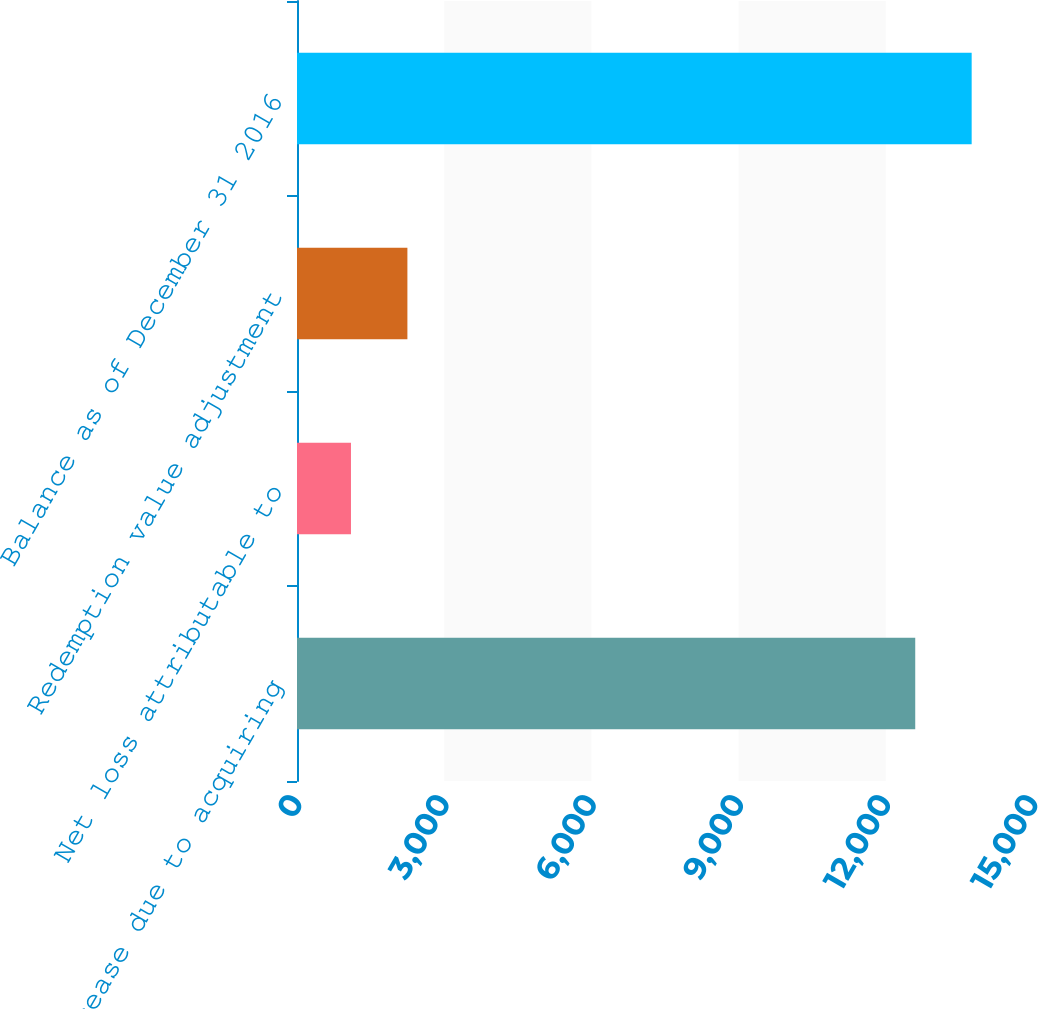<chart> <loc_0><loc_0><loc_500><loc_500><bar_chart><fcel>Increase due to acquiring<fcel>Net loss attributable to<fcel>Redemption value adjustment<fcel>Balance as of December 31 2016<nl><fcel>12600<fcel>1100<fcel>2250<fcel>13750<nl></chart> 